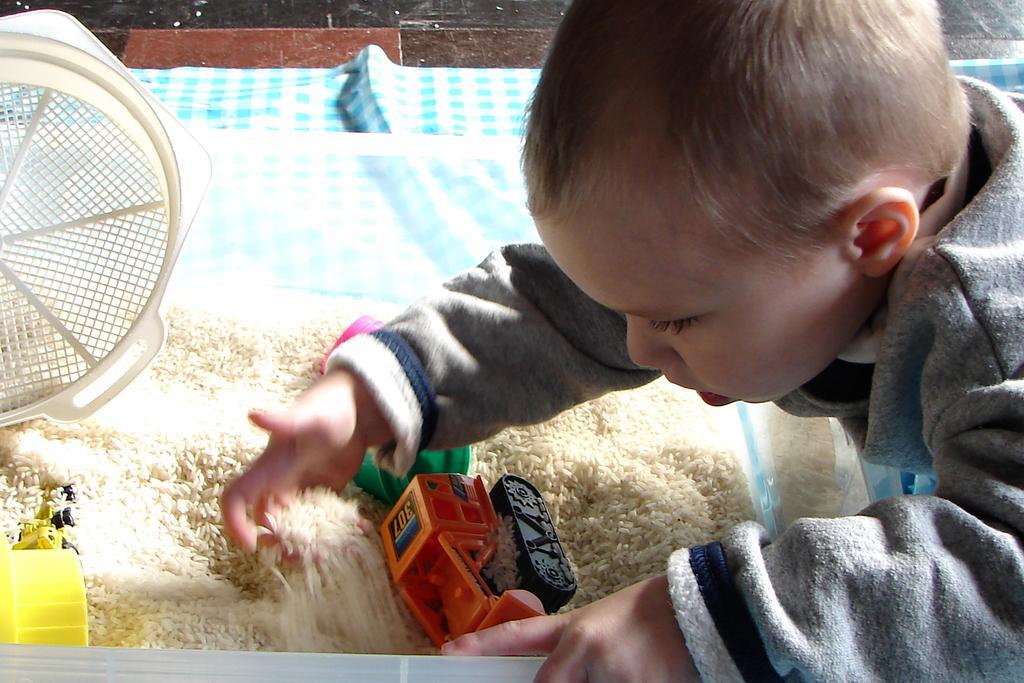Please provide a concise description of this image. A child is playing with the toys and rice. 